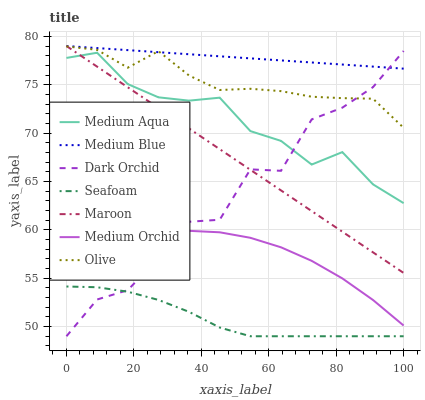Does Seafoam have the minimum area under the curve?
Answer yes or no. Yes. Does Medium Blue have the maximum area under the curve?
Answer yes or no. Yes. Does Medium Blue have the minimum area under the curve?
Answer yes or no. No. Does Seafoam have the maximum area under the curve?
Answer yes or no. No. Is Maroon the smoothest?
Answer yes or no. Yes. Is Dark Orchid the roughest?
Answer yes or no. Yes. Is Medium Blue the smoothest?
Answer yes or no. No. Is Medium Blue the roughest?
Answer yes or no. No. Does Seafoam have the lowest value?
Answer yes or no. Yes. Does Medium Blue have the lowest value?
Answer yes or no. No. Does Maroon have the highest value?
Answer yes or no. Yes. Does Seafoam have the highest value?
Answer yes or no. No. Is Seafoam less than Medium Orchid?
Answer yes or no. Yes. Is Medium Blue greater than Medium Orchid?
Answer yes or no. Yes. Does Medium Blue intersect Maroon?
Answer yes or no. Yes. Is Medium Blue less than Maroon?
Answer yes or no. No. Is Medium Blue greater than Maroon?
Answer yes or no. No. Does Seafoam intersect Medium Orchid?
Answer yes or no. No. 